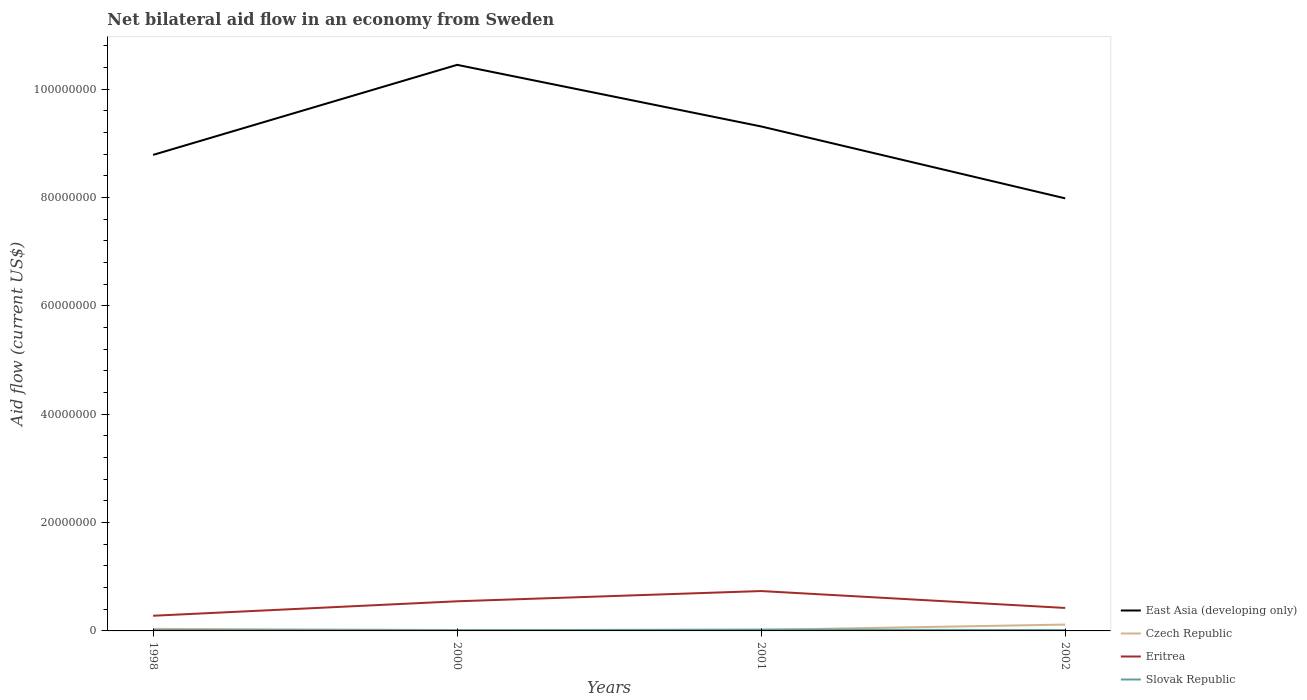Does the line corresponding to Slovak Republic intersect with the line corresponding to Czech Republic?
Offer a very short reply. Yes. Across all years, what is the maximum net bilateral aid flow in Eritrea?
Ensure brevity in your answer.  2.80e+06. What is the total net bilateral aid flow in Slovak Republic in the graph?
Give a very brief answer. 10000. What is the difference between the highest and the second highest net bilateral aid flow in Czech Republic?
Give a very brief answer. 1.00e+06. What is the difference between two consecutive major ticks on the Y-axis?
Your response must be concise. 2.00e+07. Are the values on the major ticks of Y-axis written in scientific E-notation?
Provide a succinct answer. No. Does the graph contain any zero values?
Offer a very short reply. No. Where does the legend appear in the graph?
Provide a short and direct response. Bottom right. How are the legend labels stacked?
Provide a succinct answer. Vertical. What is the title of the graph?
Make the answer very short. Net bilateral aid flow in an economy from Sweden. What is the label or title of the Y-axis?
Keep it short and to the point. Aid flow (current US$). What is the Aid flow (current US$) in East Asia (developing only) in 1998?
Offer a terse response. 8.78e+07. What is the Aid flow (current US$) of Eritrea in 1998?
Your answer should be compact. 2.80e+06. What is the Aid flow (current US$) of East Asia (developing only) in 2000?
Your answer should be very brief. 1.04e+08. What is the Aid flow (current US$) in Czech Republic in 2000?
Provide a short and direct response. 1.70e+05. What is the Aid flow (current US$) of Eritrea in 2000?
Your answer should be very brief. 5.47e+06. What is the Aid flow (current US$) in East Asia (developing only) in 2001?
Make the answer very short. 9.31e+07. What is the Aid flow (current US$) of Eritrea in 2001?
Offer a terse response. 7.36e+06. What is the Aid flow (current US$) of East Asia (developing only) in 2002?
Provide a succinct answer. 7.98e+07. What is the Aid flow (current US$) in Czech Republic in 2002?
Your answer should be compact. 1.17e+06. What is the Aid flow (current US$) of Eritrea in 2002?
Keep it short and to the point. 4.24e+06. Across all years, what is the maximum Aid flow (current US$) of East Asia (developing only)?
Make the answer very short. 1.04e+08. Across all years, what is the maximum Aid flow (current US$) of Czech Republic?
Your answer should be compact. 1.17e+06. Across all years, what is the maximum Aid flow (current US$) in Eritrea?
Your answer should be compact. 7.36e+06. Across all years, what is the maximum Aid flow (current US$) in Slovak Republic?
Your response must be concise. 2.40e+05. Across all years, what is the minimum Aid flow (current US$) in East Asia (developing only)?
Ensure brevity in your answer.  7.98e+07. Across all years, what is the minimum Aid flow (current US$) in Czech Republic?
Give a very brief answer. 1.70e+05. Across all years, what is the minimum Aid flow (current US$) of Eritrea?
Provide a succinct answer. 2.80e+06. Across all years, what is the minimum Aid flow (current US$) in Slovak Republic?
Ensure brevity in your answer.  1.20e+05. What is the total Aid flow (current US$) of East Asia (developing only) in the graph?
Offer a terse response. 3.65e+08. What is the total Aid flow (current US$) in Czech Republic in the graph?
Give a very brief answer. 1.91e+06. What is the total Aid flow (current US$) of Eritrea in the graph?
Provide a succinct answer. 1.99e+07. What is the total Aid flow (current US$) in Slovak Republic in the graph?
Keep it short and to the point. 6.90e+05. What is the difference between the Aid flow (current US$) in East Asia (developing only) in 1998 and that in 2000?
Your answer should be compact. -1.66e+07. What is the difference between the Aid flow (current US$) of Eritrea in 1998 and that in 2000?
Keep it short and to the point. -2.67e+06. What is the difference between the Aid flow (current US$) in East Asia (developing only) in 1998 and that in 2001?
Keep it short and to the point. -5.25e+06. What is the difference between the Aid flow (current US$) in Eritrea in 1998 and that in 2001?
Make the answer very short. -4.56e+06. What is the difference between the Aid flow (current US$) of East Asia (developing only) in 1998 and that in 2002?
Ensure brevity in your answer.  8.02e+06. What is the difference between the Aid flow (current US$) in Czech Republic in 1998 and that in 2002?
Give a very brief answer. -7.90e+05. What is the difference between the Aid flow (current US$) in Eritrea in 1998 and that in 2002?
Provide a succinct answer. -1.44e+06. What is the difference between the Aid flow (current US$) in Slovak Republic in 1998 and that in 2002?
Provide a short and direct response. 10000. What is the difference between the Aid flow (current US$) of East Asia (developing only) in 2000 and that in 2001?
Your response must be concise. 1.14e+07. What is the difference between the Aid flow (current US$) in Eritrea in 2000 and that in 2001?
Your response must be concise. -1.89e+06. What is the difference between the Aid flow (current US$) of East Asia (developing only) in 2000 and that in 2002?
Provide a short and direct response. 2.46e+07. What is the difference between the Aid flow (current US$) of Czech Republic in 2000 and that in 2002?
Make the answer very short. -1.00e+06. What is the difference between the Aid flow (current US$) of Eritrea in 2000 and that in 2002?
Give a very brief answer. 1.23e+06. What is the difference between the Aid flow (current US$) in East Asia (developing only) in 2001 and that in 2002?
Make the answer very short. 1.33e+07. What is the difference between the Aid flow (current US$) in Czech Republic in 2001 and that in 2002?
Your response must be concise. -9.80e+05. What is the difference between the Aid flow (current US$) in Eritrea in 2001 and that in 2002?
Your response must be concise. 3.12e+06. What is the difference between the Aid flow (current US$) in Slovak Republic in 2001 and that in 2002?
Your answer should be very brief. 8.00e+04. What is the difference between the Aid flow (current US$) in East Asia (developing only) in 1998 and the Aid flow (current US$) in Czech Republic in 2000?
Ensure brevity in your answer.  8.77e+07. What is the difference between the Aid flow (current US$) of East Asia (developing only) in 1998 and the Aid flow (current US$) of Eritrea in 2000?
Offer a very short reply. 8.24e+07. What is the difference between the Aid flow (current US$) of East Asia (developing only) in 1998 and the Aid flow (current US$) of Slovak Republic in 2000?
Keep it short and to the point. 8.77e+07. What is the difference between the Aid flow (current US$) of Czech Republic in 1998 and the Aid flow (current US$) of Eritrea in 2000?
Your answer should be compact. -5.09e+06. What is the difference between the Aid flow (current US$) of Czech Republic in 1998 and the Aid flow (current US$) of Slovak Republic in 2000?
Keep it short and to the point. 2.60e+05. What is the difference between the Aid flow (current US$) in Eritrea in 1998 and the Aid flow (current US$) in Slovak Republic in 2000?
Provide a short and direct response. 2.68e+06. What is the difference between the Aid flow (current US$) in East Asia (developing only) in 1998 and the Aid flow (current US$) in Czech Republic in 2001?
Ensure brevity in your answer.  8.77e+07. What is the difference between the Aid flow (current US$) of East Asia (developing only) in 1998 and the Aid flow (current US$) of Eritrea in 2001?
Offer a terse response. 8.05e+07. What is the difference between the Aid flow (current US$) of East Asia (developing only) in 1998 and the Aid flow (current US$) of Slovak Republic in 2001?
Keep it short and to the point. 8.76e+07. What is the difference between the Aid flow (current US$) in Czech Republic in 1998 and the Aid flow (current US$) in Eritrea in 2001?
Keep it short and to the point. -6.98e+06. What is the difference between the Aid flow (current US$) of Czech Republic in 1998 and the Aid flow (current US$) of Slovak Republic in 2001?
Offer a terse response. 1.40e+05. What is the difference between the Aid flow (current US$) in Eritrea in 1998 and the Aid flow (current US$) in Slovak Republic in 2001?
Ensure brevity in your answer.  2.56e+06. What is the difference between the Aid flow (current US$) of East Asia (developing only) in 1998 and the Aid flow (current US$) of Czech Republic in 2002?
Your response must be concise. 8.67e+07. What is the difference between the Aid flow (current US$) of East Asia (developing only) in 1998 and the Aid flow (current US$) of Eritrea in 2002?
Offer a very short reply. 8.36e+07. What is the difference between the Aid flow (current US$) of East Asia (developing only) in 1998 and the Aid flow (current US$) of Slovak Republic in 2002?
Ensure brevity in your answer.  8.77e+07. What is the difference between the Aid flow (current US$) of Czech Republic in 1998 and the Aid flow (current US$) of Eritrea in 2002?
Provide a succinct answer. -3.86e+06. What is the difference between the Aid flow (current US$) of Czech Republic in 1998 and the Aid flow (current US$) of Slovak Republic in 2002?
Offer a very short reply. 2.20e+05. What is the difference between the Aid flow (current US$) in Eritrea in 1998 and the Aid flow (current US$) in Slovak Republic in 2002?
Give a very brief answer. 2.64e+06. What is the difference between the Aid flow (current US$) in East Asia (developing only) in 2000 and the Aid flow (current US$) in Czech Republic in 2001?
Make the answer very short. 1.04e+08. What is the difference between the Aid flow (current US$) in East Asia (developing only) in 2000 and the Aid flow (current US$) in Eritrea in 2001?
Your answer should be very brief. 9.71e+07. What is the difference between the Aid flow (current US$) in East Asia (developing only) in 2000 and the Aid flow (current US$) in Slovak Republic in 2001?
Keep it short and to the point. 1.04e+08. What is the difference between the Aid flow (current US$) in Czech Republic in 2000 and the Aid flow (current US$) in Eritrea in 2001?
Your response must be concise. -7.19e+06. What is the difference between the Aid flow (current US$) of Czech Republic in 2000 and the Aid flow (current US$) of Slovak Republic in 2001?
Provide a short and direct response. -7.00e+04. What is the difference between the Aid flow (current US$) in Eritrea in 2000 and the Aid flow (current US$) in Slovak Republic in 2001?
Offer a very short reply. 5.23e+06. What is the difference between the Aid flow (current US$) in East Asia (developing only) in 2000 and the Aid flow (current US$) in Czech Republic in 2002?
Offer a very short reply. 1.03e+08. What is the difference between the Aid flow (current US$) in East Asia (developing only) in 2000 and the Aid flow (current US$) in Eritrea in 2002?
Offer a terse response. 1.00e+08. What is the difference between the Aid flow (current US$) of East Asia (developing only) in 2000 and the Aid flow (current US$) of Slovak Republic in 2002?
Provide a short and direct response. 1.04e+08. What is the difference between the Aid flow (current US$) in Czech Republic in 2000 and the Aid flow (current US$) in Eritrea in 2002?
Make the answer very short. -4.07e+06. What is the difference between the Aid flow (current US$) in Eritrea in 2000 and the Aid flow (current US$) in Slovak Republic in 2002?
Offer a terse response. 5.31e+06. What is the difference between the Aid flow (current US$) of East Asia (developing only) in 2001 and the Aid flow (current US$) of Czech Republic in 2002?
Ensure brevity in your answer.  9.19e+07. What is the difference between the Aid flow (current US$) in East Asia (developing only) in 2001 and the Aid flow (current US$) in Eritrea in 2002?
Provide a short and direct response. 8.89e+07. What is the difference between the Aid flow (current US$) of East Asia (developing only) in 2001 and the Aid flow (current US$) of Slovak Republic in 2002?
Offer a very short reply. 9.29e+07. What is the difference between the Aid flow (current US$) in Czech Republic in 2001 and the Aid flow (current US$) in Eritrea in 2002?
Make the answer very short. -4.05e+06. What is the difference between the Aid flow (current US$) of Czech Republic in 2001 and the Aid flow (current US$) of Slovak Republic in 2002?
Offer a very short reply. 3.00e+04. What is the difference between the Aid flow (current US$) in Eritrea in 2001 and the Aid flow (current US$) in Slovak Republic in 2002?
Your response must be concise. 7.20e+06. What is the average Aid flow (current US$) in East Asia (developing only) per year?
Provide a succinct answer. 9.13e+07. What is the average Aid flow (current US$) in Czech Republic per year?
Give a very brief answer. 4.78e+05. What is the average Aid flow (current US$) in Eritrea per year?
Provide a short and direct response. 4.97e+06. What is the average Aid flow (current US$) of Slovak Republic per year?
Give a very brief answer. 1.72e+05. In the year 1998, what is the difference between the Aid flow (current US$) in East Asia (developing only) and Aid flow (current US$) in Czech Republic?
Keep it short and to the point. 8.75e+07. In the year 1998, what is the difference between the Aid flow (current US$) of East Asia (developing only) and Aid flow (current US$) of Eritrea?
Provide a succinct answer. 8.50e+07. In the year 1998, what is the difference between the Aid flow (current US$) of East Asia (developing only) and Aid flow (current US$) of Slovak Republic?
Keep it short and to the point. 8.77e+07. In the year 1998, what is the difference between the Aid flow (current US$) of Czech Republic and Aid flow (current US$) of Eritrea?
Provide a short and direct response. -2.42e+06. In the year 1998, what is the difference between the Aid flow (current US$) in Czech Republic and Aid flow (current US$) in Slovak Republic?
Offer a very short reply. 2.10e+05. In the year 1998, what is the difference between the Aid flow (current US$) of Eritrea and Aid flow (current US$) of Slovak Republic?
Offer a very short reply. 2.63e+06. In the year 2000, what is the difference between the Aid flow (current US$) in East Asia (developing only) and Aid flow (current US$) in Czech Republic?
Your response must be concise. 1.04e+08. In the year 2000, what is the difference between the Aid flow (current US$) of East Asia (developing only) and Aid flow (current US$) of Eritrea?
Keep it short and to the point. 9.90e+07. In the year 2000, what is the difference between the Aid flow (current US$) of East Asia (developing only) and Aid flow (current US$) of Slovak Republic?
Your answer should be compact. 1.04e+08. In the year 2000, what is the difference between the Aid flow (current US$) of Czech Republic and Aid flow (current US$) of Eritrea?
Offer a terse response. -5.30e+06. In the year 2000, what is the difference between the Aid flow (current US$) of Eritrea and Aid flow (current US$) of Slovak Republic?
Provide a short and direct response. 5.35e+06. In the year 2001, what is the difference between the Aid flow (current US$) in East Asia (developing only) and Aid flow (current US$) in Czech Republic?
Offer a terse response. 9.29e+07. In the year 2001, what is the difference between the Aid flow (current US$) of East Asia (developing only) and Aid flow (current US$) of Eritrea?
Offer a terse response. 8.57e+07. In the year 2001, what is the difference between the Aid flow (current US$) of East Asia (developing only) and Aid flow (current US$) of Slovak Republic?
Provide a succinct answer. 9.29e+07. In the year 2001, what is the difference between the Aid flow (current US$) in Czech Republic and Aid flow (current US$) in Eritrea?
Provide a short and direct response. -7.17e+06. In the year 2001, what is the difference between the Aid flow (current US$) of Eritrea and Aid flow (current US$) of Slovak Republic?
Keep it short and to the point. 7.12e+06. In the year 2002, what is the difference between the Aid flow (current US$) in East Asia (developing only) and Aid flow (current US$) in Czech Republic?
Your answer should be very brief. 7.87e+07. In the year 2002, what is the difference between the Aid flow (current US$) in East Asia (developing only) and Aid flow (current US$) in Eritrea?
Make the answer very short. 7.56e+07. In the year 2002, what is the difference between the Aid flow (current US$) of East Asia (developing only) and Aid flow (current US$) of Slovak Republic?
Offer a very short reply. 7.97e+07. In the year 2002, what is the difference between the Aid flow (current US$) in Czech Republic and Aid flow (current US$) in Eritrea?
Your response must be concise. -3.07e+06. In the year 2002, what is the difference between the Aid flow (current US$) of Czech Republic and Aid flow (current US$) of Slovak Republic?
Make the answer very short. 1.01e+06. In the year 2002, what is the difference between the Aid flow (current US$) of Eritrea and Aid flow (current US$) of Slovak Republic?
Your answer should be very brief. 4.08e+06. What is the ratio of the Aid flow (current US$) of East Asia (developing only) in 1998 to that in 2000?
Provide a succinct answer. 0.84. What is the ratio of the Aid flow (current US$) of Czech Republic in 1998 to that in 2000?
Your answer should be very brief. 2.24. What is the ratio of the Aid flow (current US$) of Eritrea in 1998 to that in 2000?
Provide a short and direct response. 0.51. What is the ratio of the Aid flow (current US$) of Slovak Republic in 1998 to that in 2000?
Give a very brief answer. 1.42. What is the ratio of the Aid flow (current US$) in East Asia (developing only) in 1998 to that in 2001?
Keep it short and to the point. 0.94. What is the ratio of the Aid flow (current US$) in Eritrea in 1998 to that in 2001?
Offer a very short reply. 0.38. What is the ratio of the Aid flow (current US$) in Slovak Republic in 1998 to that in 2001?
Your answer should be very brief. 0.71. What is the ratio of the Aid flow (current US$) of East Asia (developing only) in 1998 to that in 2002?
Offer a terse response. 1.1. What is the ratio of the Aid flow (current US$) in Czech Republic in 1998 to that in 2002?
Offer a very short reply. 0.32. What is the ratio of the Aid flow (current US$) of Eritrea in 1998 to that in 2002?
Offer a terse response. 0.66. What is the ratio of the Aid flow (current US$) of Slovak Republic in 1998 to that in 2002?
Your answer should be compact. 1.06. What is the ratio of the Aid flow (current US$) in East Asia (developing only) in 2000 to that in 2001?
Your answer should be very brief. 1.12. What is the ratio of the Aid flow (current US$) in Czech Republic in 2000 to that in 2001?
Give a very brief answer. 0.89. What is the ratio of the Aid flow (current US$) in Eritrea in 2000 to that in 2001?
Make the answer very short. 0.74. What is the ratio of the Aid flow (current US$) of East Asia (developing only) in 2000 to that in 2002?
Offer a very short reply. 1.31. What is the ratio of the Aid flow (current US$) of Czech Republic in 2000 to that in 2002?
Make the answer very short. 0.15. What is the ratio of the Aid flow (current US$) of Eritrea in 2000 to that in 2002?
Offer a terse response. 1.29. What is the ratio of the Aid flow (current US$) in East Asia (developing only) in 2001 to that in 2002?
Offer a terse response. 1.17. What is the ratio of the Aid flow (current US$) in Czech Republic in 2001 to that in 2002?
Your answer should be very brief. 0.16. What is the ratio of the Aid flow (current US$) of Eritrea in 2001 to that in 2002?
Your response must be concise. 1.74. What is the ratio of the Aid flow (current US$) in Slovak Republic in 2001 to that in 2002?
Make the answer very short. 1.5. What is the difference between the highest and the second highest Aid flow (current US$) of East Asia (developing only)?
Offer a terse response. 1.14e+07. What is the difference between the highest and the second highest Aid flow (current US$) of Czech Republic?
Provide a succinct answer. 7.90e+05. What is the difference between the highest and the second highest Aid flow (current US$) of Eritrea?
Provide a short and direct response. 1.89e+06. What is the difference between the highest and the lowest Aid flow (current US$) in East Asia (developing only)?
Your answer should be compact. 2.46e+07. What is the difference between the highest and the lowest Aid flow (current US$) in Eritrea?
Offer a terse response. 4.56e+06. What is the difference between the highest and the lowest Aid flow (current US$) of Slovak Republic?
Ensure brevity in your answer.  1.20e+05. 